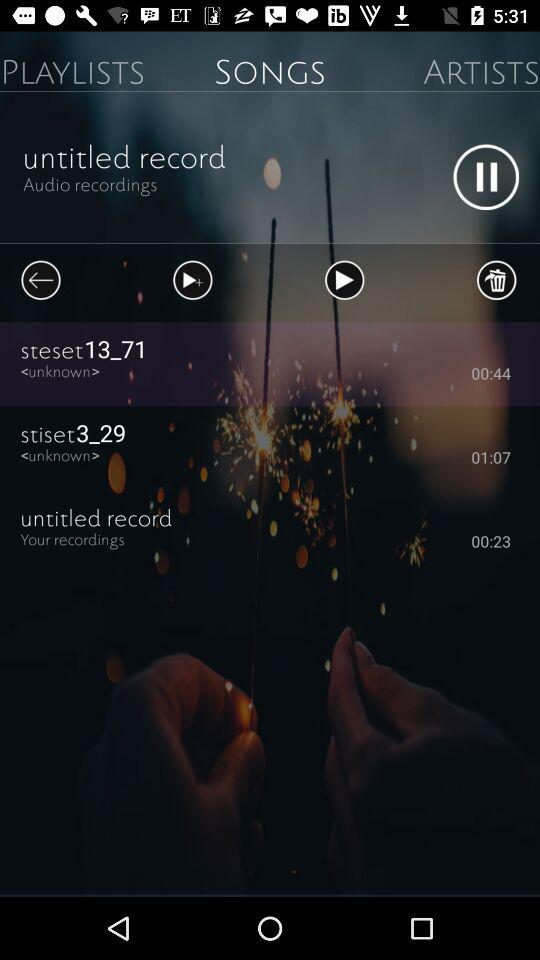What is the duration of "stiset3_29"? The duration of "stiset3_29" is 1 minute 7 seconds. 